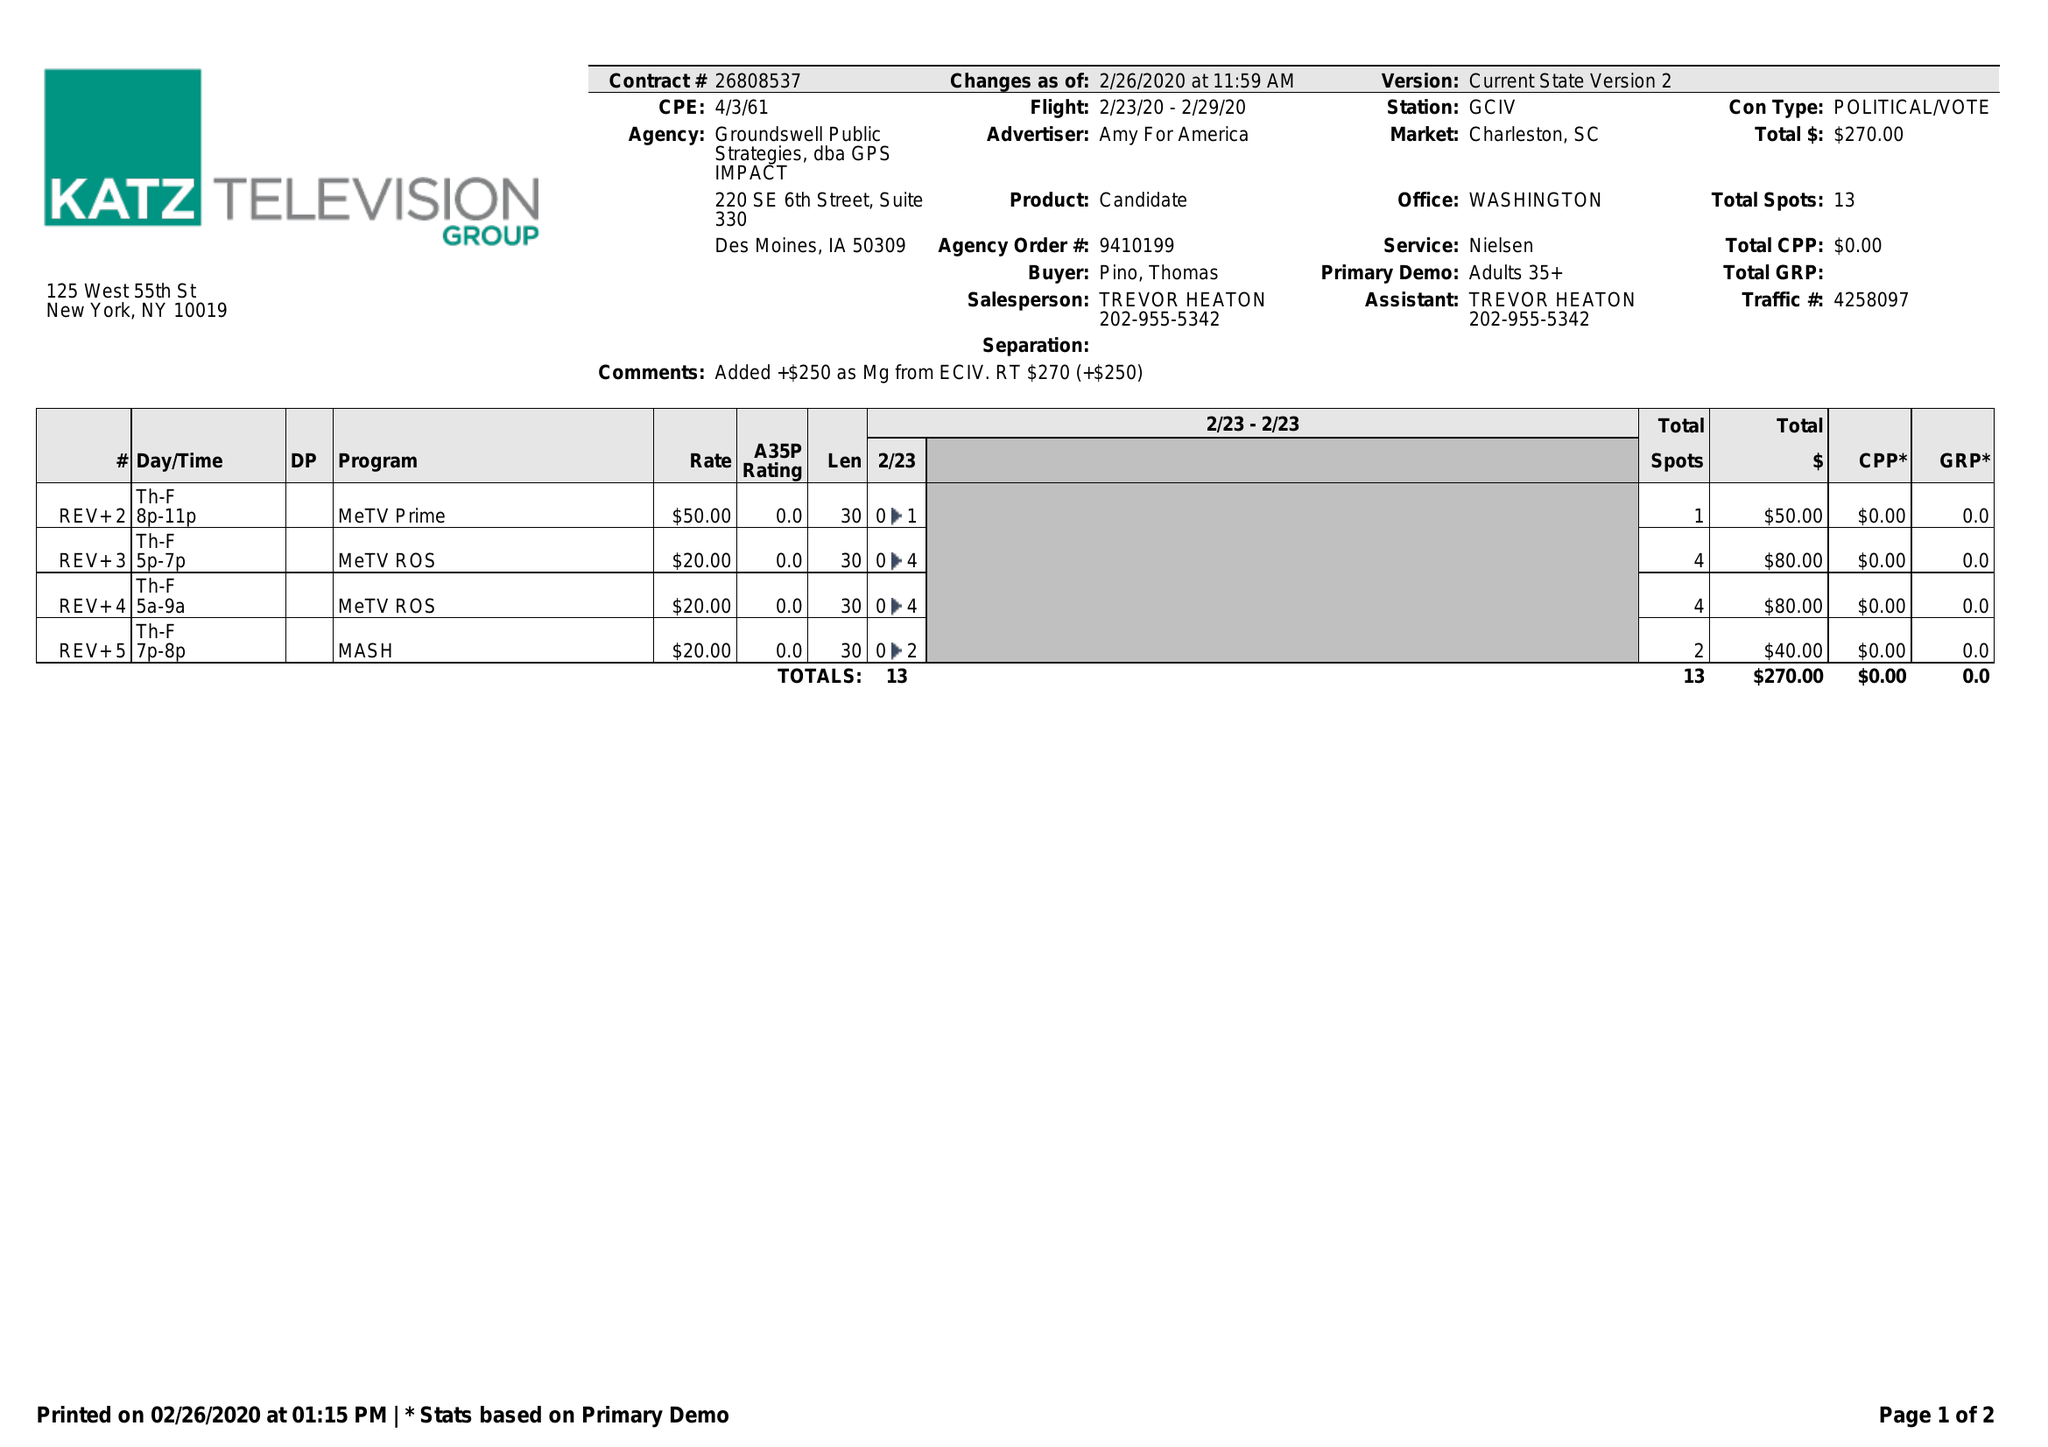What is the value for the advertiser?
Answer the question using a single word or phrase. AMY FOR AMERICA 